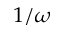<formula> <loc_0><loc_0><loc_500><loc_500>1 / \omega</formula> 